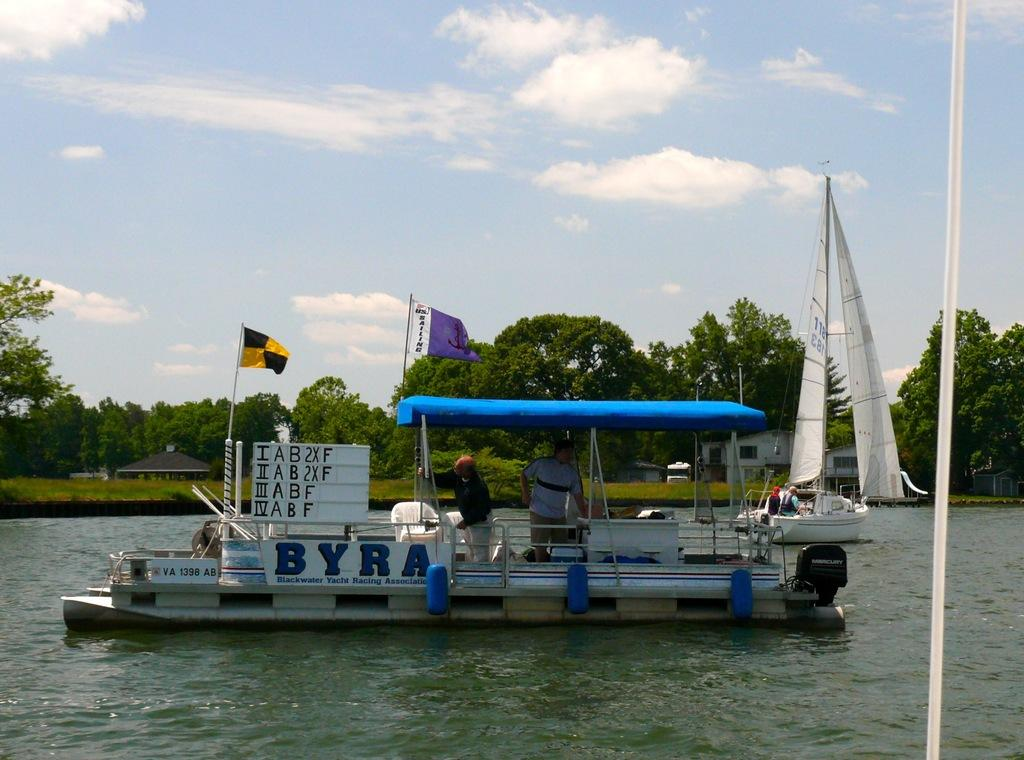<image>
Present a compact description of the photo's key features. Out on a pond a small covered boat floating on the water with the word BYRA painted on the side of the boat. 